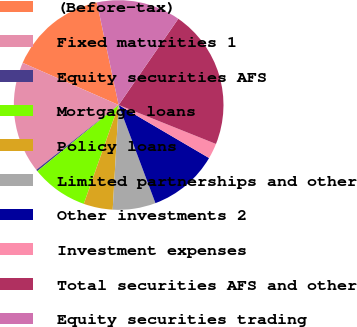Convert chart. <chart><loc_0><loc_0><loc_500><loc_500><pie_chart><fcel>(Before-tax)<fcel>Fixed maturities 1<fcel>Equity securities AFS<fcel>Mortgage loans<fcel>Policy loans<fcel>Limited partnerships and other<fcel>Other investments 2<fcel>Investment expenses<fcel>Total securities AFS and other<fcel>Equity securities trading<nl><fcel>15.08%<fcel>17.2%<fcel>0.26%<fcel>8.73%<fcel>4.49%<fcel>6.61%<fcel>10.85%<fcel>2.38%<fcel>21.43%<fcel>12.96%<nl></chart> 